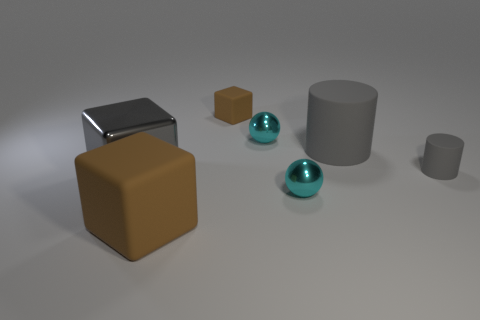Are there any purple cubes that have the same size as the gray metallic thing?
Provide a short and direct response. No. What number of objects are objects behind the gray metal thing or large things behind the large shiny block?
Make the answer very short. 4. The sphere behind the block that is left of the large brown rubber thing is what color?
Provide a short and direct response. Cyan. There is another tiny thing that is made of the same material as the tiny brown object; what is its color?
Ensure brevity in your answer.  Gray. How many small metal things are the same color as the large matte cylinder?
Your answer should be compact. 0. What number of objects are either big gray rubber cylinders or big matte objects?
Provide a succinct answer. 2. What shape is the brown rubber thing that is the same size as the shiny cube?
Your answer should be compact. Cube. How many objects are on the left side of the big gray matte cylinder and to the right of the small cube?
Provide a short and direct response. 2. There is a cyan ball that is in front of the small gray cylinder; what is it made of?
Ensure brevity in your answer.  Metal. The gray object that is made of the same material as the small cylinder is what size?
Provide a succinct answer. Large. 